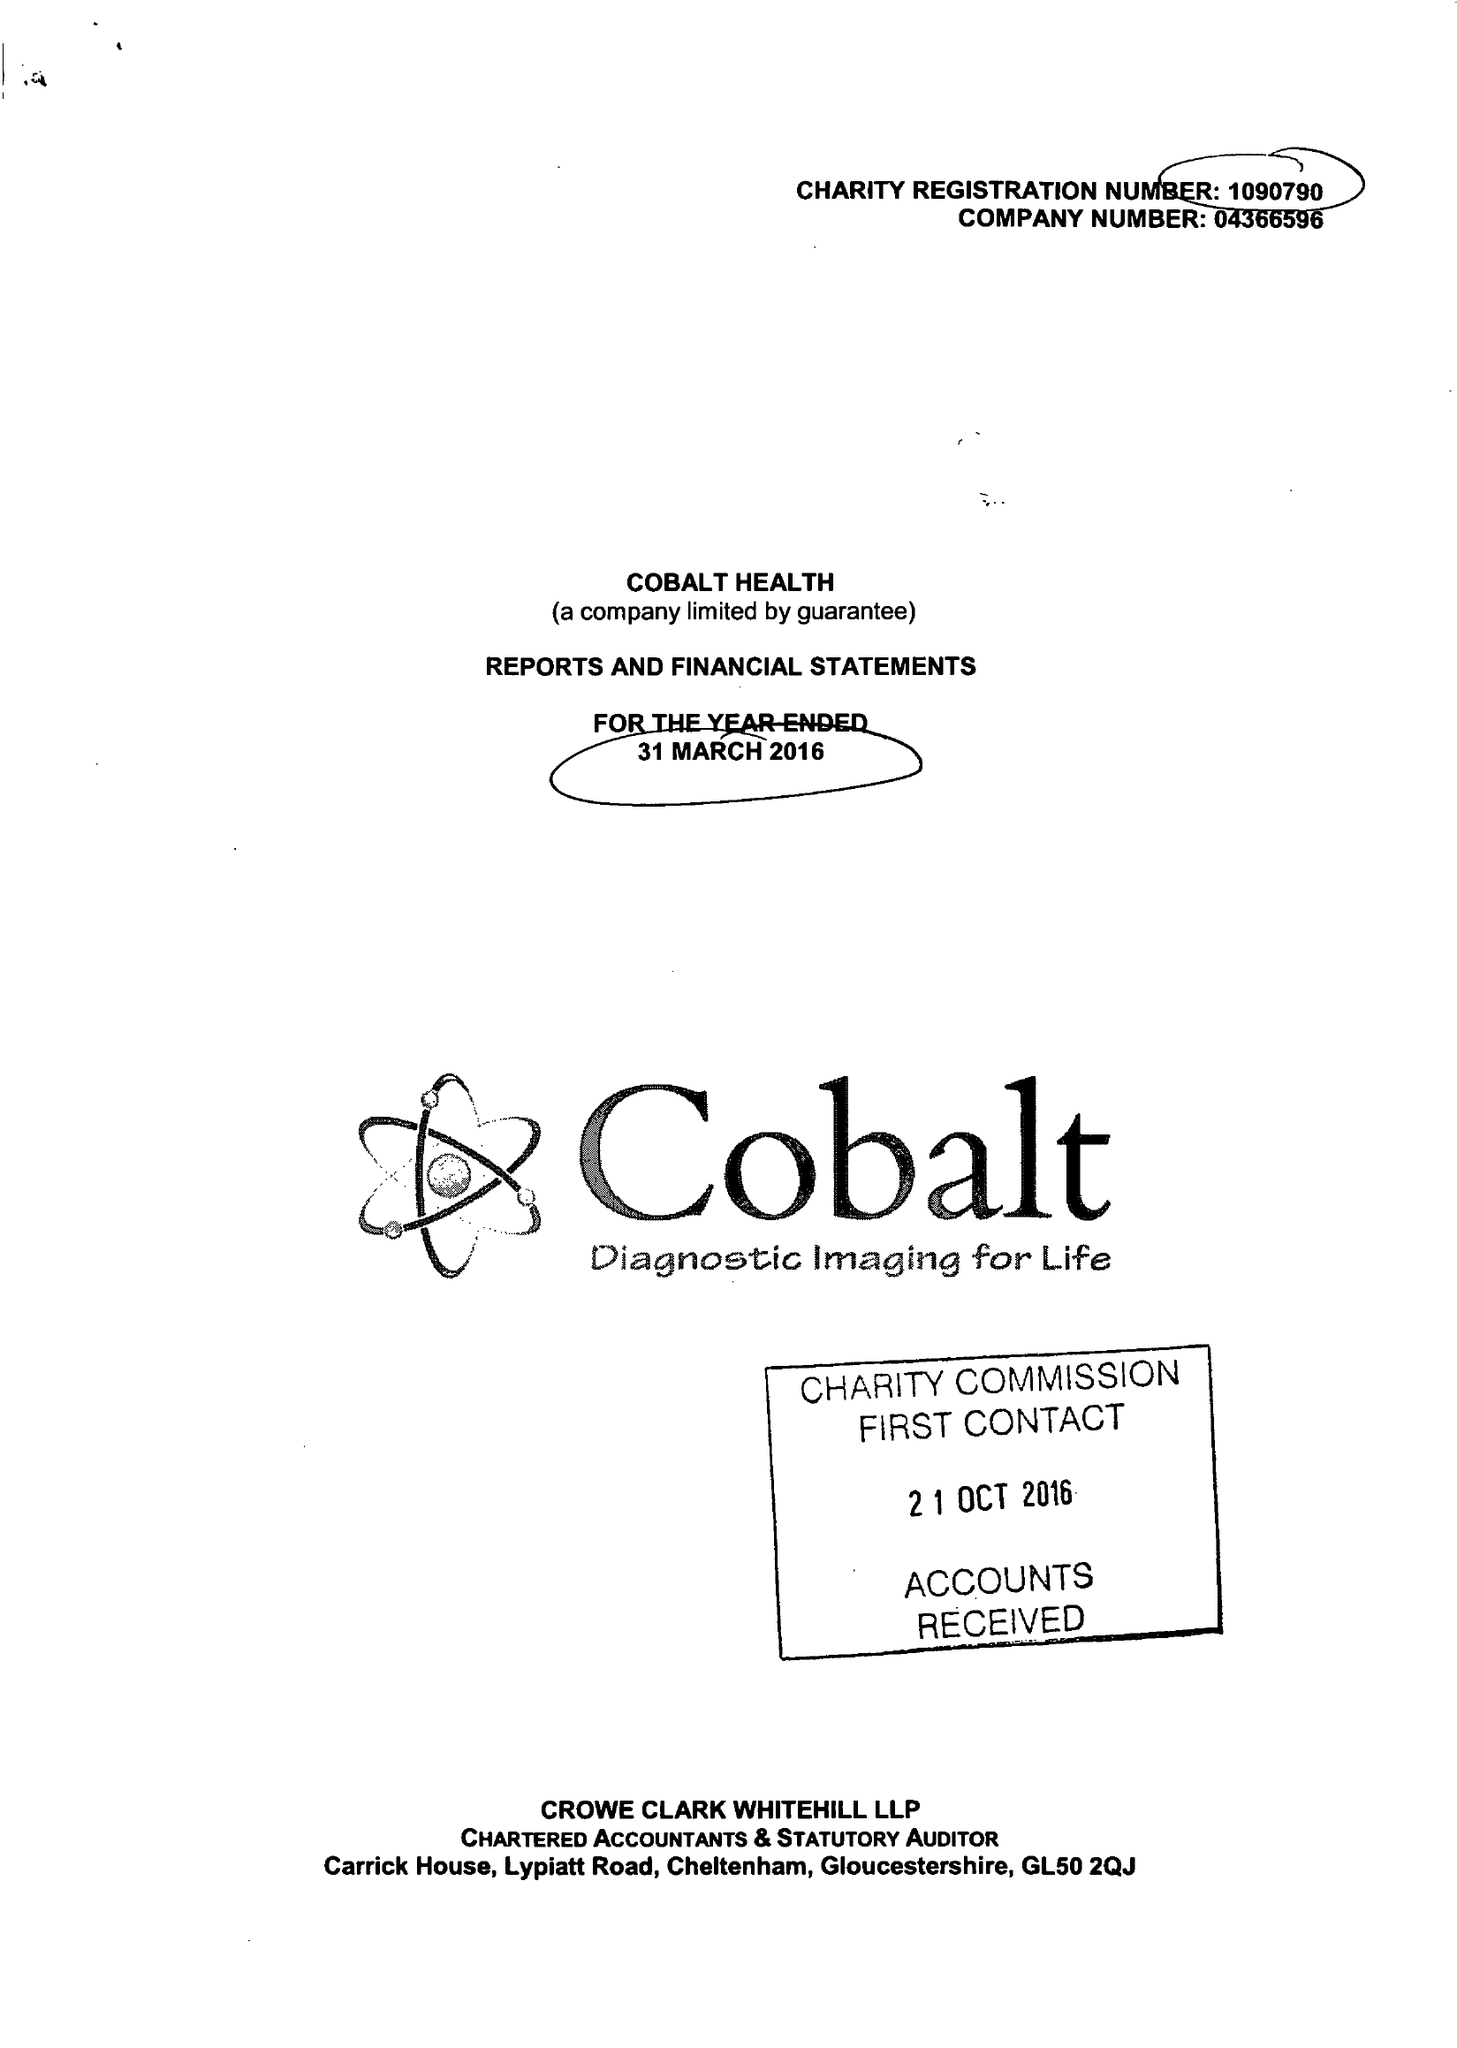What is the value for the charity_name?
Answer the question using a single word or phrase. Cobalt Health 